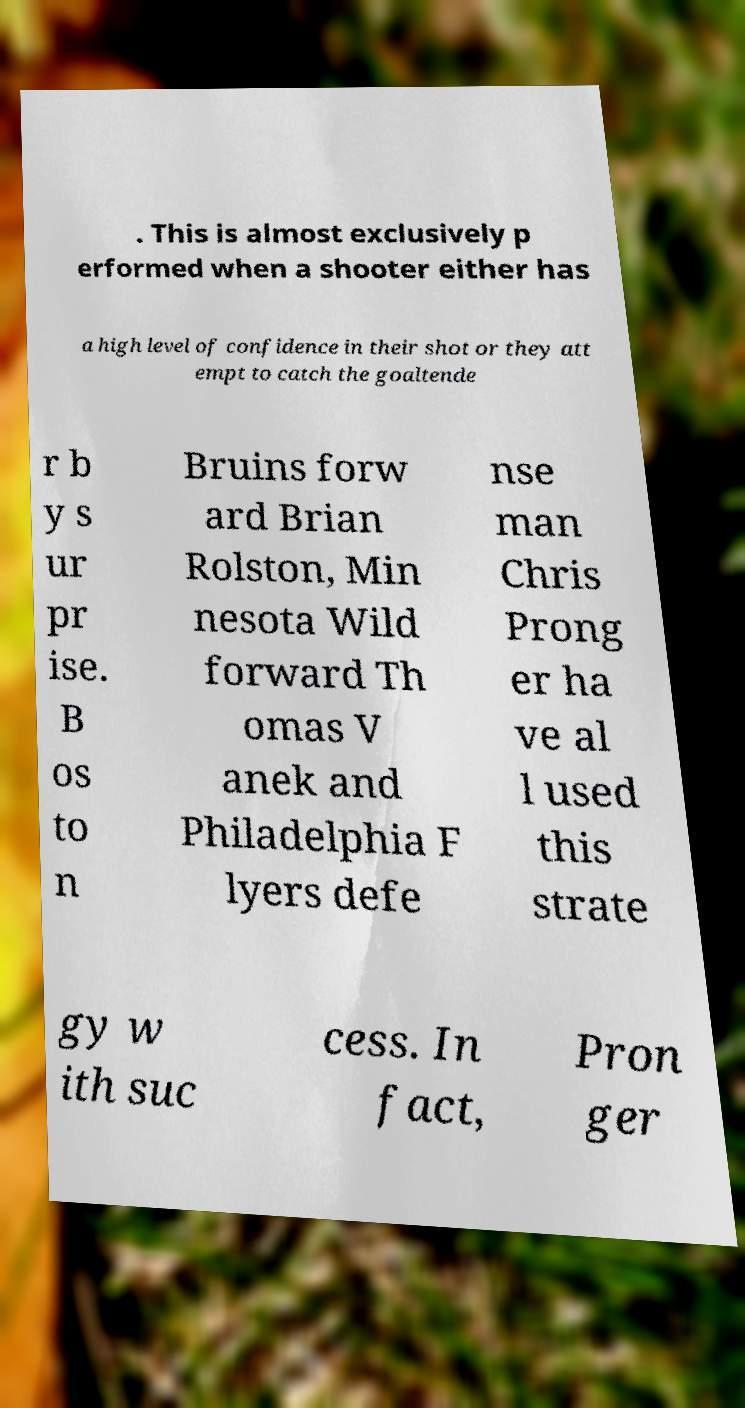For documentation purposes, I need the text within this image transcribed. Could you provide that? . This is almost exclusively p erformed when a shooter either has a high level of confidence in their shot or they att empt to catch the goaltende r b y s ur pr ise. B os to n Bruins forw ard Brian Rolston, Min nesota Wild forward Th omas V anek and Philadelphia F lyers defe nse man Chris Prong er ha ve al l used this strate gy w ith suc cess. In fact, Pron ger 